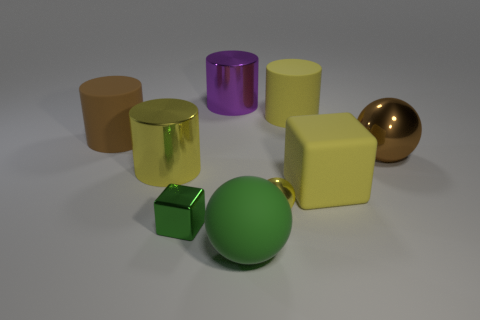Subtract all spheres. How many objects are left? 6 Add 5 big yellow shiny objects. How many big yellow shiny objects are left? 6 Add 4 brown metal blocks. How many brown metal blocks exist? 4 Subtract 0 purple cubes. How many objects are left? 9 Subtract all big matte cubes. Subtract all large yellow shiny things. How many objects are left? 7 